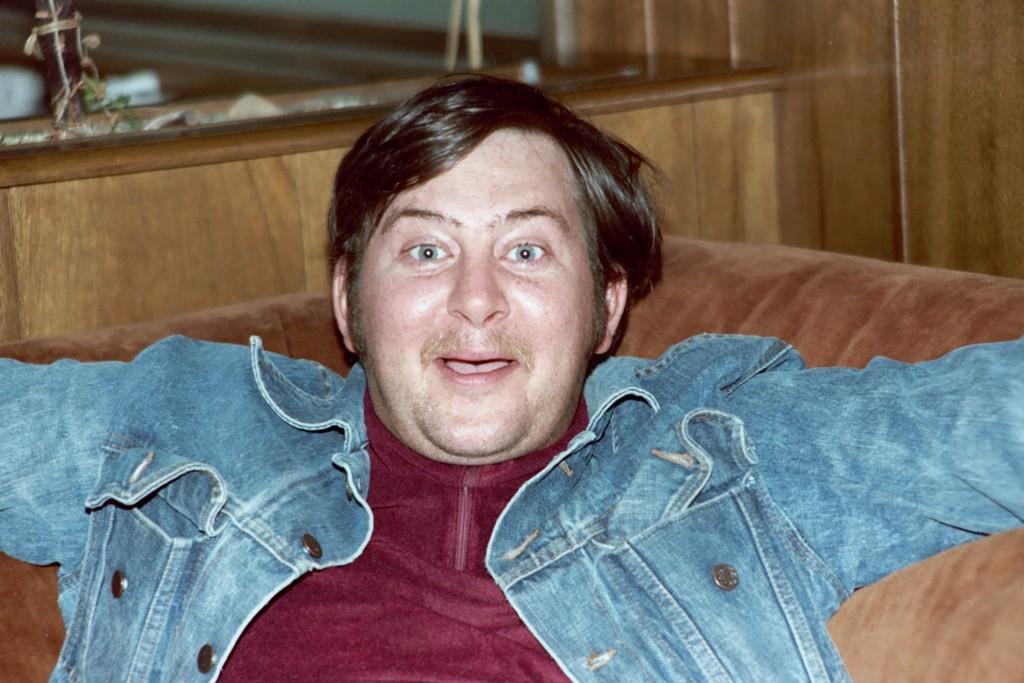Could you give a brief overview of what you see in this image? In the picture we can see a man sitting on the sofa which is brown in color and he is with red T-shirt and blue jacket and in the background we can see a wooden wall. 